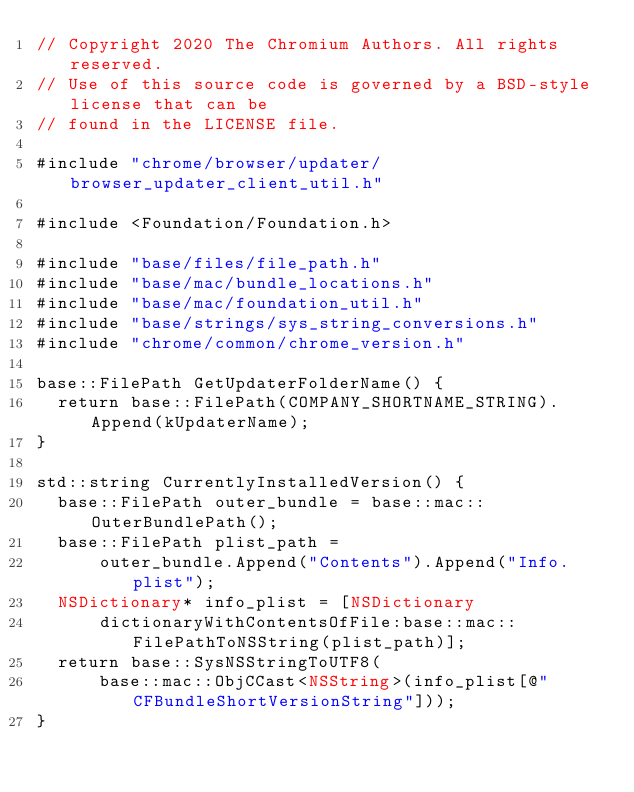Convert code to text. <code><loc_0><loc_0><loc_500><loc_500><_ObjectiveC_>// Copyright 2020 The Chromium Authors. All rights reserved.
// Use of this source code is governed by a BSD-style license that can be
// found in the LICENSE file.

#include "chrome/browser/updater/browser_updater_client_util.h"

#include <Foundation/Foundation.h>

#include "base/files/file_path.h"
#include "base/mac/bundle_locations.h"
#include "base/mac/foundation_util.h"
#include "base/strings/sys_string_conversions.h"
#include "chrome/common/chrome_version.h"

base::FilePath GetUpdaterFolderName() {
  return base::FilePath(COMPANY_SHORTNAME_STRING).Append(kUpdaterName);
}

std::string CurrentlyInstalledVersion() {
  base::FilePath outer_bundle = base::mac::OuterBundlePath();
  base::FilePath plist_path =
      outer_bundle.Append("Contents").Append("Info.plist");
  NSDictionary* info_plist = [NSDictionary
      dictionaryWithContentsOfFile:base::mac::FilePathToNSString(plist_path)];
  return base::SysNSStringToUTF8(
      base::mac::ObjCCast<NSString>(info_plist[@"CFBundleShortVersionString"]));
}
</code> 